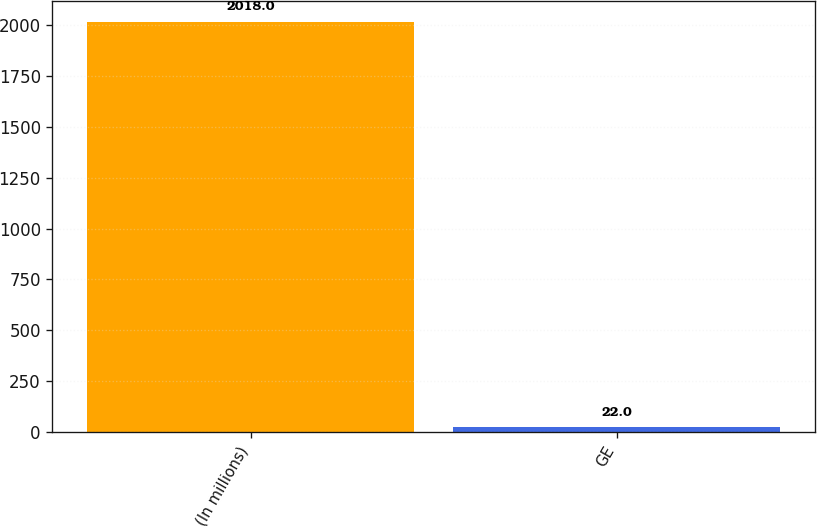Convert chart to OTSL. <chart><loc_0><loc_0><loc_500><loc_500><bar_chart><fcel>(In millions)<fcel>GE<nl><fcel>2018<fcel>22<nl></chart> 